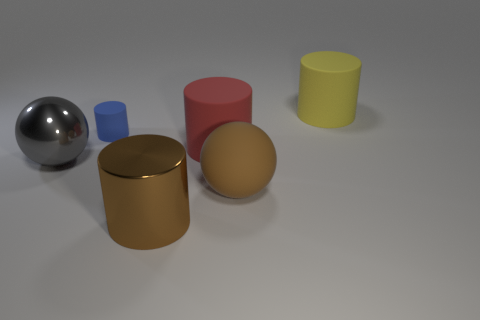Subtract all big shiny cylinders. How many cylinders are left? 3 Subtract all brown cylinders. How many cylinders are left? 3 Add 1 big gray balls. How many objects exist? 7 Subtract 3 cylinders. How many cylinders are left? 1 Subtract all cylinders. How many objects are left? 2 Subtract all gray balls. How many yellow cylinders are left? 1 Add 6 large cylinders. How many large cylinders exist? 9 Subtract 0 blue blocks. How many objects are left? 6 Subtract all green balls. Subtract all brown cubes. How many balls are left? 2 Subtract all gray matte cylinders. Subtract all yellow cylinders. How many objects are left? 5 